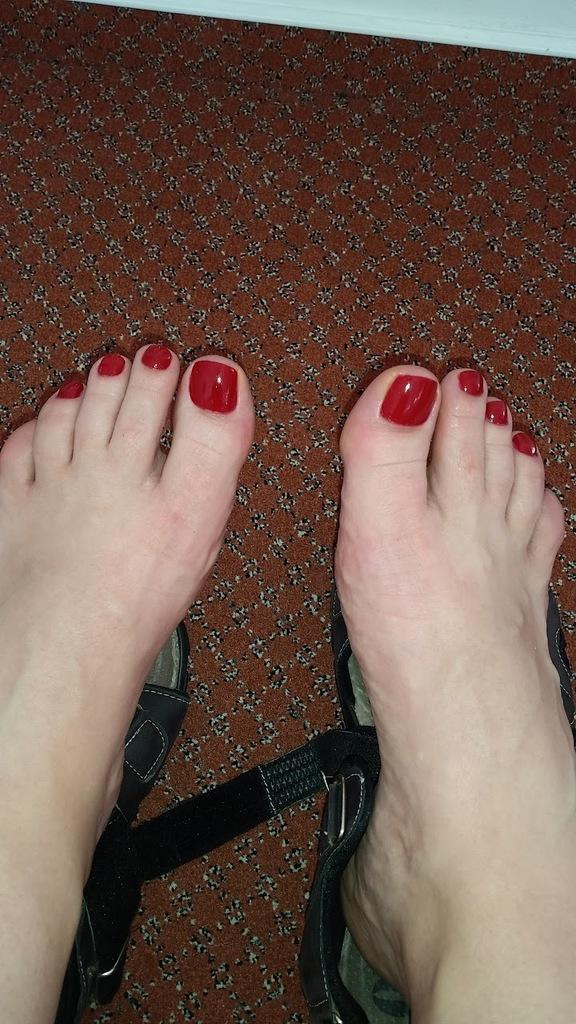What is present in the image? There is a person in the image. What type of footwear is the person wearing? The person's feet are on sandals. What type of health advice can be seen in the image? There is no health advice present in the image; it only features a person with their feet on sandals. What type of ball can be seen in the image? There is no ball present in the image. What type of ear accessory can be seen in the image? There is no ear accessory present in the image. 